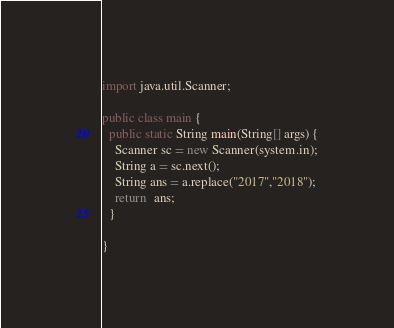<code> <loc_0><loc_0><loc_500><loc_500><_Java_>import java.util.Scanner;

public class main {
  public static String main(String[] args) {
    Scanner sc = new Scanner(system.in);
    String a = sc.next();
    String ans = a.replace("2017","2018");
    return  ans;
  }

}
</code> 